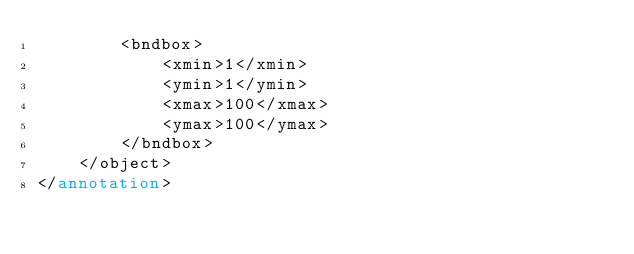<code> <loc_0><loc_0><loc_500><loc_500><_XML_>		<bndbox>
			<xmin>1</xmin>
			<ymin>1</ymin>
			<xmax>100</xmax>
			<ymax>100</ymax>
		</bndbox>
	</object>
</annotation>
</code> 